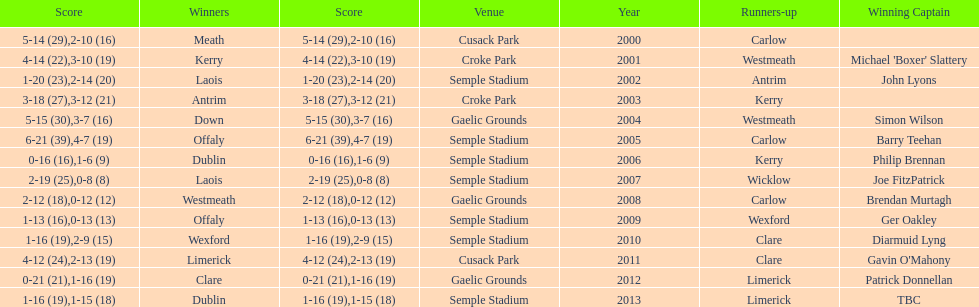What is the difference in the scores in 2000? 13. 